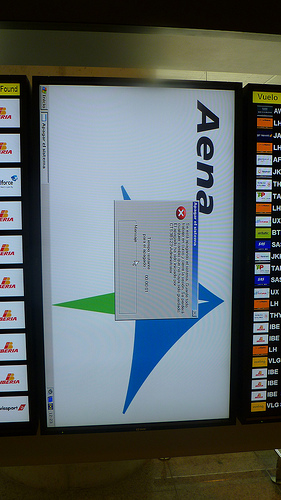<image>
Is the error message on the background? Yes. Looking at the image, I can see the error message is positioned on top of the background, with the background providing support. 